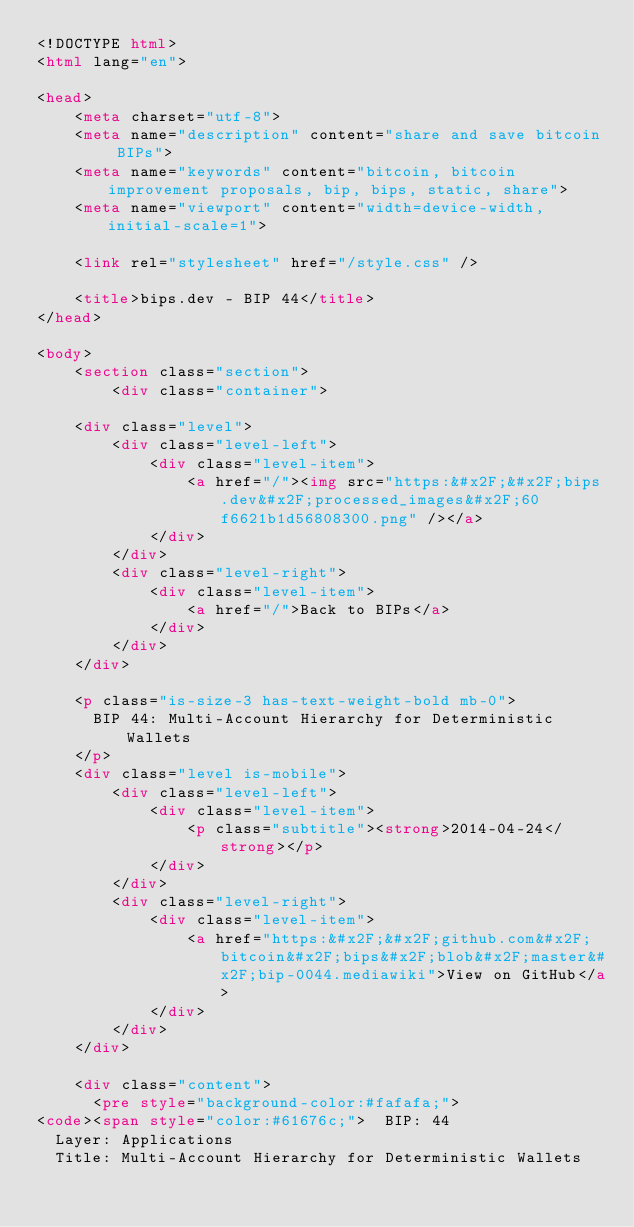Convert code to text. <code><loc_0><loc_0><loc_500><loc_500><_HTML_><!DOCTYPE html>
<html lang="en">

<head>
    <meta charset="utf-8">
    <meta name="description" content="share and save bitcoin BIPs">
    <meta name="keywords" content="bitcoin, bitcoin improvement proposals, bip, bips, static, share">
    <meta name="viewport" content="width=device-width, initial-scale=1">

    <link rel="stylesheet" href="/style.css" />

    <title>bips.dev - BIP 44</title>
</head>

<body>
    <section class="section">
        <div class="container">
            
    <div class="level">
        <div class="level-left">
            <div class="level-item">
                <a href="/"><img src="https:&#x2F;&#x2F;bips.dev&#x2F;processed_images&#x2F;60f6621b1d56808300.png" /></a>
            </div>
        </div>
        <div class="level-right">
            <div class="level-item">
                <a href="/">Back to BIPs</a>
            </div>
        </div>
    </div>

    <p class="is-size-3 has-text-weight-bold mb-0">
      BIP 44: Multi-Account Hierarchy for Deterministic Wallets
    </p>
    <div class="level is-mobile">
        <div class="level-left">
            <div class="level-item">
                <p class="subtitle"><strong>2014-04-24</strong></p>
            </div>
        </div>
        <div class="level-right">
            <div class="level-item">
                <a href="https:&#x2F;&#x2F;github.com&#x2F;bitcoin&#x2F;bips&#x2F;blob&#x2F;master&#x2F;bip-0044.mediawiki">View on GitHub</a>
            </div>
        </div>
    </div>

    <div class="content">
      <pre style="background-color:#fafafa;">
<code><span style="color:#61676c;">  BIP: 44
  Layer: Applications
  Title: Multi-Account Hierarchy for Deterministic Wallets</code> 